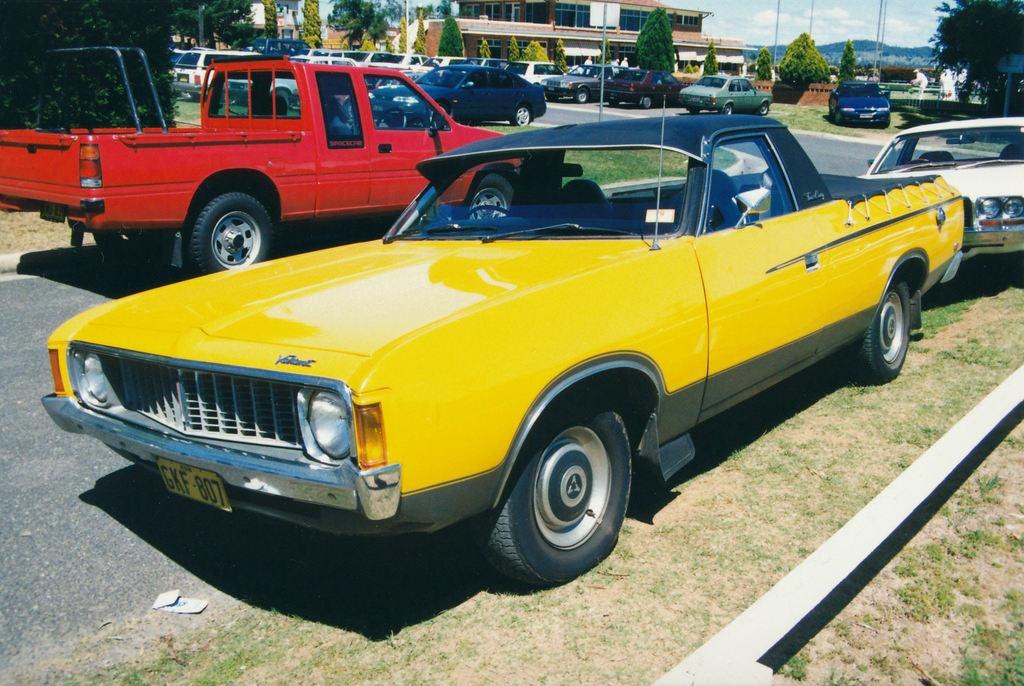What types of vehicles are present in the image? There are different colors of cars in the image. What other objects can be seen in the image besides cars? There are trees and buildings in the image. What is visible in the background of the image? The sky is visible in the image. How many sisters are playing with chalk on the territory shown in the image? There are no sisters or chalk present in the image, and no territory is mentioned or depicted. 